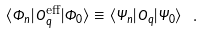Convert formula to latex. <formula><loc_0><loc_0><loc_500><loc_500>\langle \Phi _ { n } | \hat { O } _ { q } ^ { \text {eff} } | \Phi _ { 0 } \rangle \equiv \langle \Psi _ { n } | \hat { O } _ { q } | \Psi _ { 0 } \rangle \ .</formula> 